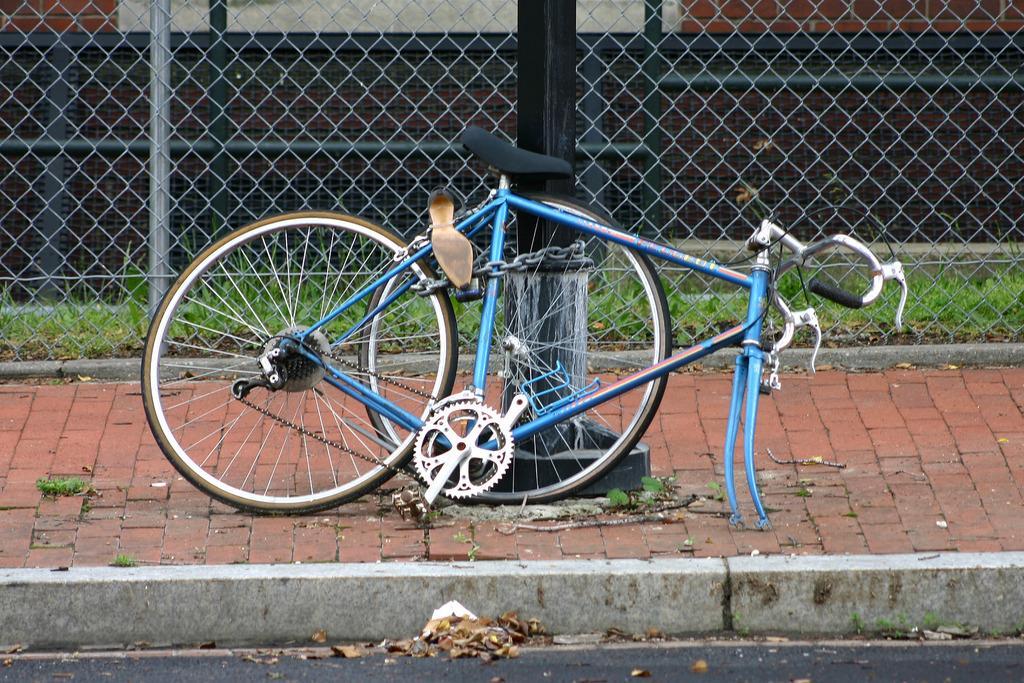How would you summarize this image in a sentence or two? In this image we can see a bicycle and a pillar, there is some grass, fence, wall and the leaves on the ground. 